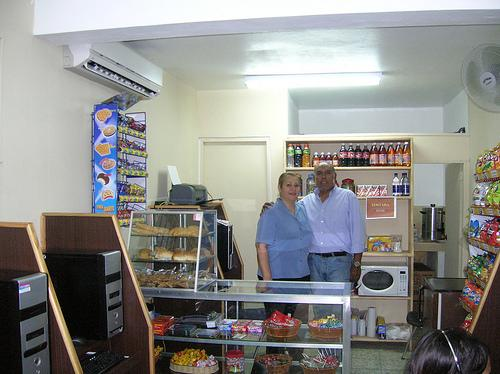Describe the clothing items visible on people in the image. A man and a woman are both wearing blue shirts, and the man also has a black belt around his waist. What is the interaction between the people in the image? A man and lady wearing blue shirts are standing together in a cafe, possibly engaged in a conversation. What do you think is the main activity being held in the background of the image? The main activity is likely shopping or browsing at a cafe/store featuring different edible products and appliances. List some of the key items that can be found on the shelves in the image. Bottles, soda drinks, chips, a white microwave, and cups stacked on a shelf are some key items visible. Describe the type of location and setting in which the image takes place. The setting is a well-stocked cafe, with various items on shelves and a display counter in the background. Describe the colors and styles of different shelves in the image. There's a large brown shelf with various items and a shelf against the wall in a lighter shade hosting cookie racks. Mention any accessories the man in the image is wearing. The man is wearing a black belt around his waist and has a watch on his wrist. Briefly mention the most prominent objects in the image. A computer modem, microwave, display case, and people wearing blue shirts are some visible objects in the image. Explain the location where the microwave and computer modem can be found in the image. A white microwave is placed on a shelf, while the computer modem is located on a desk surrounded by other objects. Narrate the scene by highlighting the main objects and characters involved. In a bustling cafe, a man and woman stand side by side, wearing blue shirts, surrounded by shelved items like bottles, chips, cookies, and several appliances. 